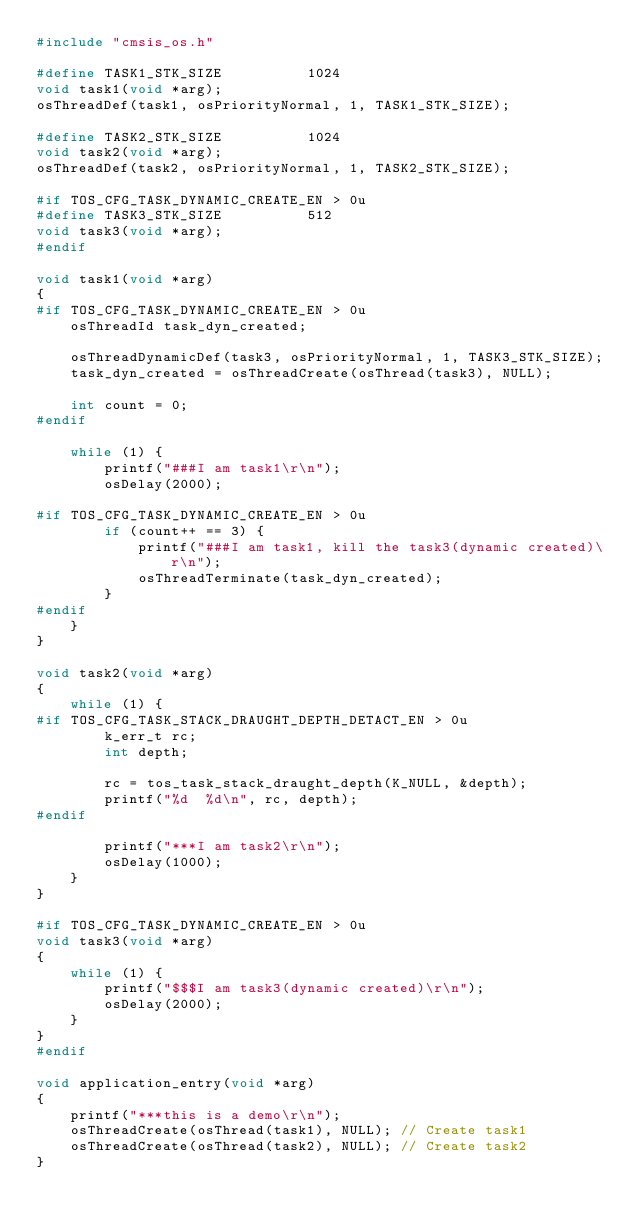Convert code to text. <code><loc_0><loc_0><loc_500><loc_500><_C_>#include "cmsis_os.h"

#define TASK1_STK_SIZE          1024
void task1(void *arg);
osThreadDef(task1, osPriorityNormal, 1, TASK1_STK_SIZE);

#define TASK2_STK_SIZE          1024
void task2(void *arg);
osThreadDef(task2, osPriorityNormal, 1, TASK2_STK_SIZE);

#if TOS_CFG_TASK_DYNAMIC_CREATE_EN > 0u
#define TASK3_STK_SIZE          512
void task3(void *arg);
#endif

void task1(void *arg)
{
#if TOS_CFG_TASK_DYNAMIC_CREATE_EN > 0u
    osThreadId task_dyn_created;

    osThreadDynamicDef(task3, osPriorityNormal, 1, TASK3_STK_SIZE);
    task_dyn_created = osThreadCreate(osThread(task3), NULL);

    int count = 0;
#endif

    while (1) {
        printf("###I am task1\r\n");
        osDelay(2000);

#if TOS_CFG_TASK_DYNAMIC_CREATE_EN > 0u
        if (count++ == 3) {
            printf("###I am task1, kill the task3(dynamic created)\r\n");
            osThreadTerminate(task_dyn_created);
        }
#endif
    }
}

void task2(void *arg)
{
    while (1) {
#if TOS_CFG_TASK_STACK_DRAUGHT_DEPTH_DETACT_EN > 0u
        k_err_t rc;
        int depth;

        rc = tos_task_stack_draught_depth(K_NULL, &depth);
        printf("%d  %d\n", rc, depth);
#endif

        printf("***I am task2\r\n");
        osDelay(1000);
    }
}

#if TOS_CFG_TASK_DYNAMIC_CREATE_EN > 0u
void task3(void *arg)
{
    while (1) {
        printf("$$$I am task3(dynamic created)\r\n");
        osDelay(2000);
    }
}
#endif

void application_entry(void *arg)
{
    printf("***this is a demo\r\n");
    osThreadCreate(osThread(task1), NULL); // Create task1
    osThreadCreate(osThread(task2), NULL); // Create task2
}

</code> 